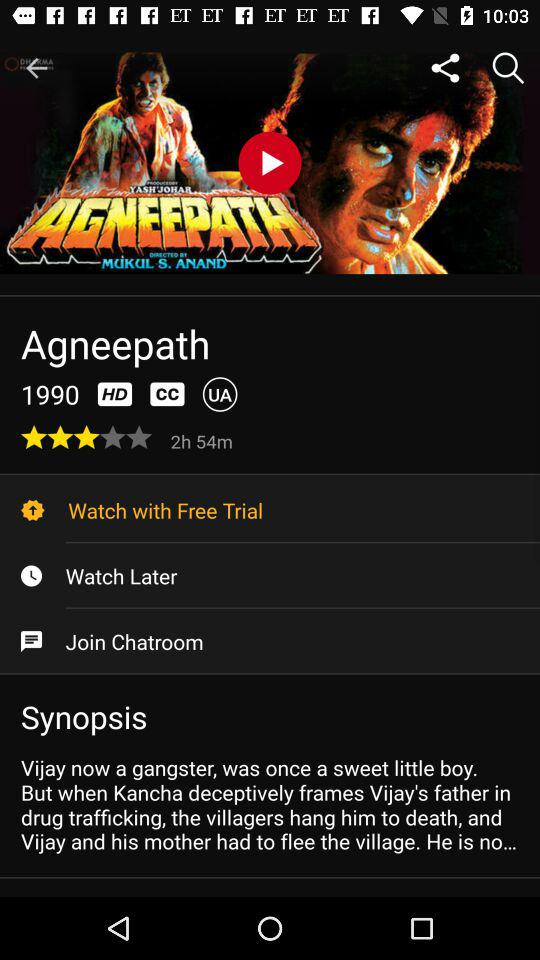What is the rating? The rating is 3 stars. 